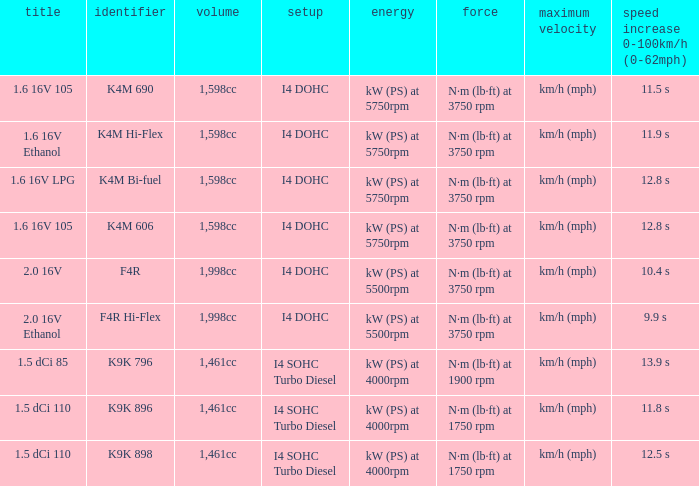What is the capacity of code f4r? 1,998cc. 